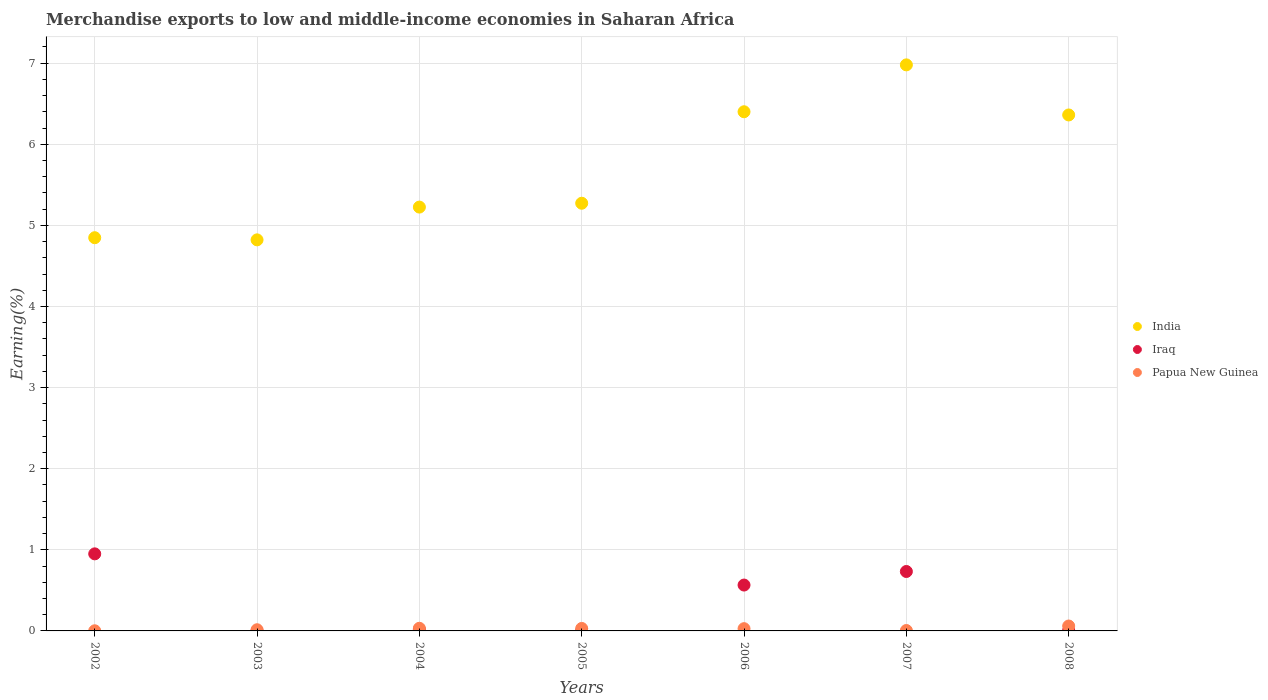How many different coloured dotlines are there?
Keep it short and to the point. 3. What is the percentage of amount earned from merchandise exports in Papua New Guinea in 2006?
Your answer should be compact. 0.03. Across all years, what is the maximum percentage of amount earned from merchandise exports in Iraq?
Ensure brevity in your answer.  0.95. Across all years, what is the minimum percentage of amount earned from merchandise exports in Papua New Guinea?
Provide a succinct answer. 0. What is the total percentage of amount earned from merchandise exports in Papua New Guinea in the graph?
Give a very brief answer. 0.17. What is the difference between the percentage of amount earned from merchandise exports in Papua New Guinea in 2004 and that in 2008?
Make the answer very short. -0.03. What is the difference between the percentage of amount earned from merchandise exports in India in 2003 and the percentage of amount earned from merchandise exports in Papua New Guinea in 2005?
Offer a very short reply. 4.79. What is the average percentage of amount earned from merchandise exports in India per year?
Ensure brevity in your answer.  5.7. In the year 2004, what is the difference between the percentage of amount earned from merchandise exports in India and percentage of amount earned from merchandise exports in Papua New Guinea?
Ensure brevity in your answer.  5.19. What is the ratio of the percentage of amount earned from merchandise exports in Papua New Guinea in 2002 to that in 2006?
Provide a short and direct response. 0.06. What is the difference between the highest and the second highest percentage of amount earned from merchandise exports in Papua New Guinea?
Your response must be concise. 0.03. What is the difference between the highest and the lowest percentage of amount earned from merchandise exports in Iraq?
Offer a very short reply. 0.95. Is it the case that in every year, the sum of the percentage of amount earned from merchandise exports in Iraq and percentage of amount earned from merchandise exports in India  is greater than the percentage of amount earned from merchandise exports in Papua New Guinea?
Make the answer very short. Yes. Is the percentage of amount earned from merchandise exports in Iraq strictly greater than the percentage of amount earned from merchandise exports in India over the years?
Offer a very short reply. No. Is the percentage of amount earned from merchandise exports in Iraq strictly less than the percentage of amount earned from merchandise exports in Papua New Guinea over the years?
Offer a very short reply. No. Does the graph contain grids?
Offer a very short reply. Yes. How many legend labels are there?
Give a very brief answer. 3. How are the legend labels stacked?
Provide a succinct answer. Vertical. What is the title of the graph?
Your answer should be compact. Merchandise exports to low and middle-income economies in Saharan Africa. Does "Tuvalu" appear as one of the legend labels in the graph?
Give a very brief answer. No. What is the label or title of the Y-axis?
Provide a succinct answer. Earning(%). What is the Earning(%) in India in 2002?
Your response must be concise. 4.85. What is the Earning(%) of Iraq in 2002?
Offer a very short reply. 0.95. What is the Earning(%) of Papua New Guinea in 2002?
Offer a terse response. 0. What is the Earning(%) in India in 2003?
Provide a short and direct response. 4.82. What is the Earning(%) in Iraq in 2003?
Your response must be concise. 0. What is the Earning(%) in Papua New Guinea in 2003?
Your answer should be very brief. 0.01. What is the Earning(%) in India in 2004?
Make the answer very short. 5.23. What is the Earning(%) in Iraq in 2004?
Offer a terse response. 0.02. What is the Earning(%) of Papua New Guinea in 2004?
Keep it short and to the point. 0.03. What is the Earning(%) of India in 2005?
Keep it short and to the point. 5.27. What is the Earning(%) of Iraq in 2005?
Give a very brief answer. 0. What is the Earning(%) of Papua New Guinea in 2005?
Provide a short and direct response. 0.03. What is the Earning(%) of India in 2006?
Offer a terse response. 6.4. What is the Earning(%) of Iraq in 2006?
Give a very brief answer. 0.57. What is the Earning(%) in Papua New Guinea in 2006?
Your answer should be very brief. 0.03. What is the Earning(%) of India in 2007?
Your answer should be very brief. 6.98. What is the Earning(%) in Iraq in 2007?
Keep it short and to the point. 0.73. What is the Earning(%) of Papua New Guinea in 2007?
Give a very brief answer. 0.01. What is the Earning(%) in India in 2008?
Give a very brief answer. 6.36. What is the Earning(%) of Iraq in 2008?
Your answer should be compact. 0.01. What is the Earning(%) in Papua New Guinea in 2008?
Give a very brief answer. 0.06. Across all years, what is the maximum Earning(%) of India?
Offer a terse response. 6.98. Across all years, what is the maximum Earning(%) of Iraq?
Provide a succinct answer. 0.95. Across all years, what is the maximum Earning(%) of Papua New Guinea?
Keep it short and to the point. 0.06. Across all years, what is the minimum Earning(%) of India?
Give a very brief answer. 4.82. Across all years, what is the minimum Earning(%) in Iraq?
Ensure brevity in your answer.  0. Across all years, what is the minimum Earning(%) of Papua New Guinea?
Ensure brevity in your answer.  0. What is the total Earning(%) in India in the graph?
Your response must be concise. 39.91. What is the total Earning(%) in Iraq in the graph?
Offer a terse response. 2.28. What is the total Earning(%) of Papua New Guinea in the graph?
Ensure brevity in your answer.  0.17. What is the difference between the Earning(%) in India in 2002 and that in 2003?
Give a very brief answer. 0.03. What is the difference between the Earning(%) in Iraq in 2002 and that in 2003?
Your answer should be compact. 0.95. What is the difference between the Earning(%) in Papua New Guinea in 2002 and that in 2003?
Make the answer very short. -0.01. What is the difference between the Earning(%) in India in 2002 and that in 2004?
Your answer should be very brief. -0.38. What is the difference between the Earning(%) of Iraq in 2002 and that in 2004?
Provide a succinct answer. 0.93. What is the difference between the Earning(%) in Papua New Guinea in 2002 and that in 2004?
Provide a succinct answer. -0.03. What is the difference between the Earning(%) of India in 2002 and that in 2005?
Give a very brief answer. -0.43. What is the difference between the Earning(%) in Iraq in 2002 and that in 2005?
Offer a terse response. 0.95. What is the difference between the Earning(%) in Papua New Guinea in 2002 and that in 2005?
Provide a succinct answer. -0.03. What is the difference between the Earning(%) of India in 2002 and that in 2006?
Give a very brief answer. -1.55. What is the difference between the Earning(%) in Iraq in 2002 and that in 2006?
Keep it short and to the point. 0.38. What is the difference between the Earning(%) in Papua New Guinea in 2002 and that in 2006?
Provide a succinct answer. -0.03. What is the difference between the Earning(%) in India in 2002 and that in 2007?
Offer a terse response. -2.13. What is the difference between the Earning(%) of Iraq in 2002 and that in 2007?
Give a very brief answer. 0.22. What is the difference between the Earning(%) of Papua New Guinea in 2002 and that in 2007?
Offer a terse response. -0. What is the difference between the Earning(%) of India in 2002 and that in 2008?
Provide a short and direct response. -1.51. What is the difference between the Earning(%) in Iraq in 2002 and that in 2008?
Your answer should be compact. 0.94. What is the difference between the Earning(%) of Papua New Guinea in 2002 and that in 2008?
Ensure brevity in your answer.  -0.06. What is the difference between the Earning(%) in India in 2003 and that in 2004?
Make the answer very short. -0.4. What is the difference between the Earning(%) of Iraq in 2003 and that in 2004?
Make the answer very short. -0.02. What is the difference between the Earning(%) in Papua New Guinea in 2003 and that in 2004?
Your response must be concise. -0.02. What is the difference between the Earning(%) in India in 2003 and that in 2005?
Offer a very short reply. -0.45. What is the difference between the Earning(%) of Iraq in 2003 and that in 2005?
Your answer should be compact. -0. What is the difference between the Earning(%) in Papua New Guinea in 2003 and that in 2005?
Offer a very short reply. -0.02. What is the difference between the Earning(%) in India in 2003 and that in 2006?
Make the answer very short. -1.58. What is the difference between the Earning(%) in Iraq in 2003 and that in 2006?
Offer a very short reply. -0.56. What is the difference between the Earning(%) of Papua New Guinea in 2003 and that in 2006?
Offer a terse response. -0.01. What is the difference between the Earning(%) in India in 2003 and that in 2007?
Provide a short and direct response. -2.16. What is the difference between the Earning(%) of Iraq in 2003 and that in 2007?
Provide a succinct answer. -0.73. What is the difference between the Earning(%) of Papua New Guinea in 2003 and that in 2007?
Provide a short and direct response. 0.01. What is the difference between the Earning(%) of India in 2003 and that in 2008?
Provide a succinct answer. -1.54. What is the difference between the Earning(%) in Iraq in 2003 and that in 2008?
Make the answer very short. -0.01. What is the difference between the Earning(%) in Papua New Guinea in 2003 and that in 2008?
Your answer should be very brief. -0.05. What is the difference between the Earning(%) in India in 2004 and that in 2005?
Offer a very short reply. -0.05. What is the difference between the Earning(%) in Iraq in 2004 and that in 2005?
Provide a succinct answer. 0.01. What is the difference between the Earning(%) in Papua New Guinea in 2004 and that in 2005?
Keep it short and to the point. 0. What is the difference between the Earning(%) in India in 2004 and that in 2006?
Make the answer very short. -1.18. What is the difference between the Earning(%) in Iraq in 2004 and that in 2006?
Give a very brief answer. -0.55. What is the difference between the Earning(%) in Papua New Guinea in 2004 and that in 2006?
Make the answer very short. 0. What is the difference between the Earning(%) in India in 2004 and that in 2007?
Provide a succinct answer. -1.75. What is the difference between the Earning(%) in Iraq in 2004 and that in 2007?
Provide a succinct answer. -0.71. What is the difference between the Earning(%) of Papua New Guinea in 2004 and that in 2007?
Your answer should be very brief. 0.03. What is the difference between the Earning(%) of India in 2004 and that in 2008?
Your answer should be very brief. -1.14. What is the difference between the Earning(%) in Iraq in 2004 and that in 2008?
Offer a terse response. 0.01. What is the difference between the Earning(%) of Papua New Guinea in 2004 and that in 2008?
Your answer should be compact. -0.03. What is the difference between the Earning(%) in India in 2005 and that in 2006?
Your response must be concise. -1.13. What is the difference between the Earning(%) of Iraq in 2005 and that in 2006?
Your answer should be very brief. -0.56. What is the difference between the Earning(%) of Papua New Guinea in 2005 and that in 2006?
Give a very brief answer. 0. What is the difference between the Earning(%) of India in 2005 and that in 2007?
Ensure brevity in your answer.  -1.71. What is the difference between the Earning(%) in Iraq in 2005 and that in 2007?
Your answer should be very brief. -0.73. What is the difference between the Earning(%) in Papua New Guinea in 2005 and that in 2007?
Keep it short and to the point. 0.03. What is the difference between the Earning(%) in India in 2005 and that in 2008?
Make the answer very short. -1.09. What is the difference between the Earning(%) in Iraq in 2005 and that in 2008?
Your answer should be compact. -0. What is the difference between the Earning(%) of Papua New Guinea in 2005 and that in 2008?
Offer a very short reply. -0.03. What is the difference between the Earning(%) in India in 2006 and that in 2007?
Offer a terse response. -0.58. What is the difference between the Earning(%) of Iraq in 2006 and that in 2007?
Your response must be concise. -0.17. What is the difference between the Earning(%) in Papua New Guinea in 2006 and that in 2007?
Your response must be concise. 0.02. What is the difference between the Earning(%) of India in 2006 and that in 2008?
Offer a very short reply. 0.04. What is the difference between the Earning(%) of Iraq in 2006 and that in 2008?
Provide a succinct answer. 0.56. What is the difference between the Earning(%) of Papua New Guinea in 2006 and that in 2008?
Offer a very short reply. -0.03. What is the difference between the Earning(%) in India in 2007 and that in 2008?
Keep it short and to the point. 0.62. What is the difference between the Earning(%) of Iraq in 2007 and that in 2008?
Offer a very short reply. 0.73. What is the difference between the Earning(%) of Papua New Guinea in 2007 and that in 2008?
Your response must be concise. -0.06. What is the difference between the Earning(%) in India in 2002 and the Earning(%) in Iraq in 2003?
Provide a short and direct response. 4.85. What is the difference between the Earning(%) in India in 2002 and the Earning(%) in Papua New Guinea in 2003?
Offer a very short reply. 4.83. What is the difference between the Earning(%) in Iraq in 2002 and the Earning(%) in Papua New Guinea in 2003?
Keep it short and to the point. 0.94. What is the difference between the Earning(%) of India in 2002 and the Earning(%) of Iraq in 2004?
Make the answer very short. 4.83. What is the difference between the Earning(%) in India in 2002 and the Earning(%) in Papua New Guinea in 2004?
Your answer should be very brief. 4.82. What is the difference between the Earning(%) in Iraq in 2002 and the Earning(%) in Papua New Guinea in 2004?
Make the answer very short. 0.92. What is the difference between the Earning(%) in India in 2002 and the Earning(%) in Iraq in 2005?
Give a very brief answer. 4.84. What is the difference between the Earning(%) of India in 2002 and the Earning(%) of Papua New Guinea in 2005?
Your answer should be very brief. 4.82. What is the difference between the Earning(%) of Iraq in 2002 and the Earning(%) of Papua New Guinea in 2005?
Your answer should be compact. 0.92. What is the difference between the Earning(%) of India in 2002 and the Earning(%) of Iraq in 2006?
Your response must be concise. 4.28. What is the difference between the Earning(%) of India in 2002 and the Earning(%) of Papua New Guinea in 2006?
Offer a very short reply. 4.82. What is the difference between the Earning(%) in Iraq in 2002 and the Earning(%) in Papua New Guinea in 2006?
Offer a terse response. 0.92. What is the difference between the Earning(%) in India in 2002 and the Earning(%) in Iraq in 2007?
Your answer should be very brief. 4.12. What is the difference between the Earning(%) in India in 2002 and the Earning(%) in Papua New Guinea in 2007?
Your answer should be compact. 4.84. What is the difference between the Earning(%) in Iraq in 2002 and the Earning(%) in Papua New Guinea in 2007?
Your answer should be compact. 0.95. What is the difference between the Earning(%) in India in 2002 and the Earning(%) in Iraq in 2008?
Provide a short and direct response. 4.84. What is the difference between the Earning(%) in India in 2002 and the Earning(%) in Papua New Guinea in 2008?
Offer a terse response. 4.79. What is the difference between the Earning(%) of Iraq in 2002 and the Earning(%) of Papua New Guinea in 2008?
Keep it short and to the point. 0.89. What is the difference between the Earning(%) of India in 2003 and the Earning(%) of Iraq in 2004?
Ensure brevity in your answer.  4.8. What is the difference between the Earning(%) in India in 2003 and the Earning(%) in Papua New Guinea in 2004?
Offer a very short reply. 4.79. What is the difference between the Earning(%) of Iraq in 2003 and the Earning(%) of Papua New Guinea in 2004?
Make the answer very short. -0.03. What is the difference between the Earning(%) in India in 2003 and the Earning(%) in Iraq in 2005?
Keep it short and to the point. 4.82. What is the difference between the Earning(%) in India in 2003 and the Earning(%) in Papua New Guinea in 2005?
Your answer should be compact. 4.79. What is the difference between the Earning(%) of Iraq in 2003 and the Earning(%) of Papua New Guinea in 2005?
Make the answer very short. -0.03. What is the difference between the Earning(%) of India in 2003 and the Earning(%) of Iraq in 2006?
Provide a succinct answer. 4.26. What is the difference between the Earning(%) in India in 2003 and the Earning(%) in Papua New Guinea in 2006?
Offer a very short reply. 4.79. What is the difference between the Earning(%) in Iraq in 2003 and the Earning(%) in Papua New Guinea in 2006?
Provide a short and direct response. -0.03. What is the difference between the Earning(%) in India in 2003 and the Earning(%) in Iraq in 2007?
Offer a very short reply. 4.09. What is the difference between the Earning(%) of India in 2003 and the Earning(%) of Papua New Guinea in 2007?
Make the answer very short. 4.82. What is the difference between the Earning(%) in Iraq in 2003 and the Earning(%) in Papua New Guinea in 2007?
Ensure brevity in your answer.  -0. What is the difference between the Earning(%) in India in 2003 and the Earning(%) in Iraq in 2008?
Give a very brief answer. 4.81. What is the difference between the Earning(%) of India in 2003 and the Earning(%) of Papua New Guinea in 2008?
Keep it short and to the point. 4.76. What is the difference between the Earning(%) in Iraq in 2003 and the Earning(%) in Papua New Guinea in 2008?
Your answer should be compact. -0.06. What is the difference between the Earning(%) in India in 2004 and the Earning(%) in Iraq in 2005?
Ensure brevity in your answer.  5.22. What is the difference between the Earning(%) in India in 2004 and the Earning(%) in Papua New Guinea in 2005?
Keep it short and to the point. 5.19. What is the difference between the Earning(%) of Iraq in 2004 and the Earning(%) of Papua New Guinea in 2005?
Your answer should be compact. -0.01. What is the difference between the Earning(%) in India in 2004 and the Earning(%) in Iraq in 2006?
Your response must be concise. 4.66. What is the difference between the Earning(%) of India in 2004 and the Earning(%) of Papua New Guinea in 2006?
Your answer should be very brief. 5.2. What is the difference between the Earning(%) of Iraq in 2004 and the Earning(%) of Papua New Guinea in 2006?
Provide a succinct answer. -0.01. What is the difference between the Earning(%) in India in 2004 and the Earning(%) in Iraq in 2007?
Keep it short and to the point. 4.49. What is the difference between the Earning(%) of India in 2004 and the Earning(%) of Papua New Guinea in 2007?
Your response must be concise. 5.22. What is the difference between the Earning(%) in Iraq in 2004 and the Earning(%) in Papua New Guinea in 2007?
Ensure brevity in your answer.  0.01. What is the difference between the Earning(%) in India in 2004 and the Earning(%) in Iraq in 2008?
Your answer should be very brief. 5.22. What is the difference between the Earning(%) of India in 2004 and the Earning(%) of Papua New Guinea in 2008?
Give a very brief answer. 5.16. What is the difference between the Earning(%) of Iraq in 2004 and the Earning(%) of Papua New Guinea in 2008?
Offer a very short reply. -0.04. What is the difference between the Earning(%) of India in 2005 and the Earning(%) of Iraq in 2006?
Provide a short and direct response. 4.71. What is the difference between the Earning(%) in India in 2005 and the Earning(%) in Papua New Guinea in 2006?
Offer a very short reply. 5.25. What is the difference between the Earning(%) in Iraq in 2005 and the Earning(%) in Papua New Guinea in 2006?
Provide a short and direct response. -0.02. What is the difference between the Earning(%) in India in 2005 and the Earning(%) in Iraq in 2007?
Provide a succinct answer. 4.54. What is the difference between the Earning(%) in India in 2005 and the Earning(%) in Papua New Guinea in 2007?
Provide a short and direct response. 5.27. What is the difference between the Earning(%) in Iraq in 2005 and the Earning(%) in Papua New Guinea in 2007?
Your answer should be compact. -0. What is the difference between the Earning(%) in India in 2005 and the Earning(%) in Iraq in 2008?
Provide a succinct answer. 5.27. What is the difference between the Earning(%) of India in 2005 and the Earning(%) of Papua New Guinea in 2008?
Your answer should be compact. 5.21. What is the difference between the Earning(%) in Iraq in 2005 and the Earning(%) in Papua New Guinea in 2008?
Your answer should be very brief. -0.06. What is the difference between the Earning(%) in India in 2006 and the Earning(%) in Iraq in 2007?
Offer a terse response. 5.67. What is the difference between the Earning(%) of India in 2006 and the Earning(%) of Papua New Guinea in 2007?
Your answer should be very brief. 6.4. What is the difference between the Earning(%) in Iraq in 2006 and the Earning(%) in Papua New Guinea in 2007?
Provide a succinct answer. 0.56. What is the difference between the Earning(%) of India in 2006 and the Earning(%) of Iraq in 2008?
Provide a short and direct response. 6.39. What is the difference between the Earning(%) of India in 2006 and the Earning(%) of Papua New Guinea in 2008?
Provide a succinct answer. 6.34. What is the difference between the Earning(%) of Iraq in 2006 and the Earning(%) of Papua New Guinea in 2008?
Give a very brief answer. 0.51. What is the difference between the Earning(%) of India in 2007 and the Earning(%) of Iraq in 2008?
Give a very brief answer. 6.97. What is the difference between the Earning(%) of India in 2007 and the Earning(%) of Papua New Guinea in 2008?
Offer a very short reply. 6.92. What is the difference between the Earning(%) of Iraq in 2007 and the Earning(%) of Papua New Guinea in 2008?
Your answer should be compact. 0.67. What is the average Earning(%) in India per year?
Make the answer very short. 5.7. What is the average Earning(%) of Iraq per year?
Provide a succinct answer. 0.33. What is the average Earning(%) of Papua New Guinea per year?
Keep it short and to the point. 0.02. In the year 2002, what is the difference between the Earning(%) in India and Earning(%) in Iraq?
Your response must be concise. 3.9. In the year 2002, what is the difference between the Earning(%) in India and Earning(%) in Papua New Guinea?
Provide a short and direct response. 4.85. In the year 2002, what is the difference between the Earning(%) in Iraq and Earning(%) in Papua New Guinea?
Provide a short and direct response. 0.95. In the year 2003, what is the difference between the Earning(%) of India and Earning(%) of Iraq?
Keep it short and to the point. 4.82. In the year 2003, what is the difference between the Earning(%) of India and Earning(%) of Papua New Guinea?
Your answer should be compact. 4.81. In the year 2003, what is the difference between the Earning(%) in Iraq and Earning(%) in Papua New Guinea?
Provide a succinct answer. -0.01. In the year 2004, what is the difference between the Earning(%) in India and Earning(%) in Iraq?
Keep it short and to the point. 5.21. In the year 2004, what is the difference between the Earning(%) in India and Earning(%) in Papua New Guinea?
Offer a very short reply. 5.19. In the year 2004, what is the difference between the Earning(%) in Iraq and Earning(%) in Papua New Guinea?
Make the answer very short. -0.01. In the year 2005, what is the difference between the Earning(%) of India and Earning(%) of Iraq?
Offer a terse response. 5.27. In the year 2005, what is the difference between the Earning(%) of India and Earning(%) of Papua New Guinea?
Your response must be concise. 5.24. In the year 2005, what is the difference between the Earning(%) of Iraq and Earning(%) of Papua New Guinea?
Make the answer very short. -0.03. In the year 2006, what is the difference between the Earning(%) of India and Earning(%) of Iraq?
Offer a very short reply. 5.84. In the year 2006, what is the difference between the Earning(%) of India and Earning(%) of Papua New Guinea?
Offer a very short reply. 6.37. In the year 2006, what is the difference between the Earning(%) in Iraq and Earning(%) in Papua New Guinea?
Make the answer very short. 0.54. In the year 2007, what is the difference between the Earning(%) of India and Earning(%) of Iraq?
Offer a very short reply. 6.25. In the year 2007, what is the difference between the Earning(%) of India and Earning(%) of Papua New Guinea?
Make the answer very short. 6.97. In the year 2007, what is the difference between the Earning(%) in Iraq and Earning(%) in Papua New Guinea?
Offer a terse response. 0.73. In the year 2008, what is the difference between the Earning(%) of India and Earning(%) of Iraq?
Your response must be concise. 6.35. In the year 2008, what is the difference between the Earning(%) of India and Earning(%) of Papua New Guinea?
Provide a short and direct response. 6.3. In the year 2008, what is the difference between the Earning(%) in Iraq and Earning(%) in Papua New Guinea?
Give a very brief answer. -0.05. What is the ratio of the Earning(%) in Iraq in 2002 to that in 2003?
Ensure brevity in your answer.  493.97. What is the ratio of the Earning(%) of Papua New Guinea in 2002 to that in 2003?
Provide a succinct answer. 0.12. What is the ratio of the Earning(%) in India in 2002 to that in 2004?
Provide a succinct answer. 0.93. What is the ratio of the Earning(%) of Iraq in 2002 to that in 2004?
Keep it short and to the point. 53.32. What is the ratio of the Earning(%) in Papua New Guinea in 2002 to that in 2004?
Offer a terse response. 0.05. What is the ratio of the Earning(%) in India in 2002 to that in 2005?
Provide a short and direct response. 0.92. What is the ratio of the Earning(%) of Iraq in 2002 to that in 2005?
Ensure brevity in your answer.  210.3. What is the ratio of the Earning(%) of Papua New Guinea in 2002 to that in 2005?
Make the answer very short. 0.06. What is the ratio of the Earning(%) in India in 2002 to that in 2006?
Offer a terse response. 0.76. What is the ratio of the Earning(%) of Iraq in 2002 to that in 2006?
Give a very brief answer. 1.68. What is the ratio of the Earning(%) of Papua New Guinea in 2002 to that in 2006?
Provide a succinct answer. 0.06. What is the ratio of the Earning(%) of India in 2002 to that in 2007?
Your answer should be compact. 0.69. What is the ratio of the Earning(%) of Iraq in 2002 to that in 2007?
Provide a succinct answer. 1.3. What is the ratio of the Earning(%) in Papua New Guinea in 2002 to that in 2007?
Make the answer very short. 0.34. What is the ratio of the Earning(%) in India in 2002 to that in 2008?
Your answer should be compact. 0.76. What is the ratio of the Earning(%) of Iraq in 2002 to that in 2008?
Make the answer very short. 125.17. What is the ratio of the Earning(%) of Papua New Guinea in 2002 to that in 2008?
Your answer should be compact. 0.03. What is the ratio of the Earning(%) in India in 2003 to that in 2004?
Ensure brevity in your answer.  0.92. What is the ratio of the Earning(%) in Iraq in 2003 to that in 2004?
Your answer should be compact. 0.11. What is the ratio of the Earning(%) in Papua New Guinea in 2003 to that in 2004?
Keep it short and to the point. 0.44. What is the ratio of the Earning(%) in India in 2003 to that in 2005?
Provide a short and direct response. 0.91. What is the ratio of the Earning(%) of Iraq in 2003 to that in 2005?
Provide a succinct answer. 0.43. What is the ratio of the Earning(%) in Papua New Guinea in 2003 to that in 2005?
Offer a very short reply. 0.47. What is the ratio of the Earning(%) in India in 2003 to that in 2006?
Your answer should be compact. 0.75. What is the ratio of the Earning(%) in Iraq in 2003 to that in 2006?
Your answer should be compact. 0. What is the ratio of the Earning(%) in Papua New Guinea in 2003 to that in 2006?
Make the answer very short. 0.52. What is the ratio of the Earning(%) of India in 2003 to that in 2007?
Keep it short and to the point. 0.69. What is the ratio of the Earning(%) in Iraq in 2003 to that in 2007?
Your answer should be very brief. 0. What is the ratio of the Earning(%) in Papua New Guinea in 2003 to that in 2007?
Your answer should be compact. 2.89. What is the ratio of the Earning(%) in India in 2003 to that in 2008?
Your answer should be very brief. 0.76. What is the ratio of the Earning(%) of Iraq in 2003 to that in 2008?
Make the answer very short. 0.25. What is the ratio of the Earning(%) of Papua New Guinea in 2003 to that in 2008?
Offer a terse response. 0.24. What is the ratio of the Earning(%) in India in 2004 to that in 2005?
Offer a terse response. 0.99. What is the ratio of the Earning(%) in Iraq in 2004 to that in 2005?
Provide a succinct answer. 3.94. What is the ratio of the Earning(%) in Papua New Guinea in 2004 to that in 2005?
Your answer should be very brief. 1.07. What is the ratio of the Earning(%) of India in 2004 to that in 2006?
Offer a terse response. 0.82. What is the ratio of the Earning(%) of Iraq in 2004 to that in 2006?
Make the answer very short. 0.03. What is the ratio of the Earning(%) of Papua New Guinea in 2004 to that in 2006?
Your answer should be compact. 1.18. What is the ratio of the Earning(%) of India in 2004 to that in 2007?
Keep it short and to the point. 0.75. What is the ratio of the Earning(%) in Iraq in 2004 to that in 2007?
Make the answer very short. 0.02. What is the ratio of the Earning(%) of Papua New Guinea in 2004 to that in 2007?
Ensure brevity in your answer.  6.5. What is the ratio of the Earning(%) of India in 2004 to that in 2008?
Your answer should be very brief. 0.82. What is the ratio of the Earning(%) in Iraq in 2004 to that in 2008?
Provide a short and direct response. 2.35. What is the ratio of the Earning(%) in Papua New Guinea in 2004 to that in 2008?
Provide a short and direct response. 0.54. What is the ratio of the Earning(%) of India in 2005 to that in 2006?
Your answer should be compact. 0.82. What is the ratio of the Earning(%) of Iraq in 2005 to that in 2006?
Keep it short and to the point. 0.01. What is the ratio of the Earning(%) of Papua New Guinea in 2005 to that in 2006?
Make the answer very short. 1.1. What is the ratio of the Earning(%) in India in 2005 to that in 2007?
Your answer should be compact. 0.76. What is the ratio of the Earning(%) in Iraq in 2005 to that in 2007?
Your answer should be very brief. 0.01. What is the ratio of the Earning(%) in Papua New Guinea in 2005 to that in 2007?
Ensure brevity in your answer.  6.1. What is the ratio of the Earning(%) in India in 2005 to that in 2008?
Give a very brief answer. 0.83. What is the ratio of the Earning(%) of Iraq in 2005 to that in 2008?
Provide a succinct answer. 0.6. What is the ratio of the Earning(%) of Papua New Guinea in 2005 to that in 2008?
Make the answer very short. 0.51. What is the ratio of the Earning(%) of India in 2006 to that in 2007?
Give a very brief answer. 0.92. What is the ratio of the Earning(%) in Iraq in 2006 to that in 2007?
Your answer should be compact. 0.77. What is the ratio of the Earning(%) in Papua New Guinea in 2006 to that in 2007?
Your answer should be very brief. 5.52. What is the ratio of the Earning(%) of India in 2006 to that in 2008?
Provide a succinct answer. 1.01. What is the ratio of the Earning(%) of Iraq in 2006 to that in 2008?
Offer a very short reply. 74.5. What is the ratio of the Earning(%) of Papua New Guinea in 2006 to that in 2008?
Offer a very short reply. 0.46. What is the ratio of the Earning(%) in India in 2007 to that in 2008?
Offer a terse response. 1.1. What is the ratio of the Earning(%) in Iraq in 2007 to that in 2008?
Your answer should be compact. 96.52. What is the ratio of the Earning(%) of Papua New Guinea in 2007 to that in 2008?
Give a very brief answer. 0.08. What is the difference between the highest and the second highest Earning(%) in India?
Make the answer very short. 0.58. What is the difference between the highest and the second highest Earning(%) of Iraq?
Offer a terse response. 0.22. What is the difference between the highest and the second highest Earning(%) of Papua New Guinea?
Your answer should be very brief. 0.03. What is the difference between the highest and the lowest Earning(%) of India?
Ensure brevity in your answer.  2.16. What is the difference between the highest and the lowest Earning(%) in Iraq?
Ensure brevity in your answer.  0.95. What is the difference between the highest and the lowest Earning(%) of Papua New Guinea?
Offer a very short reply. 0.06. 